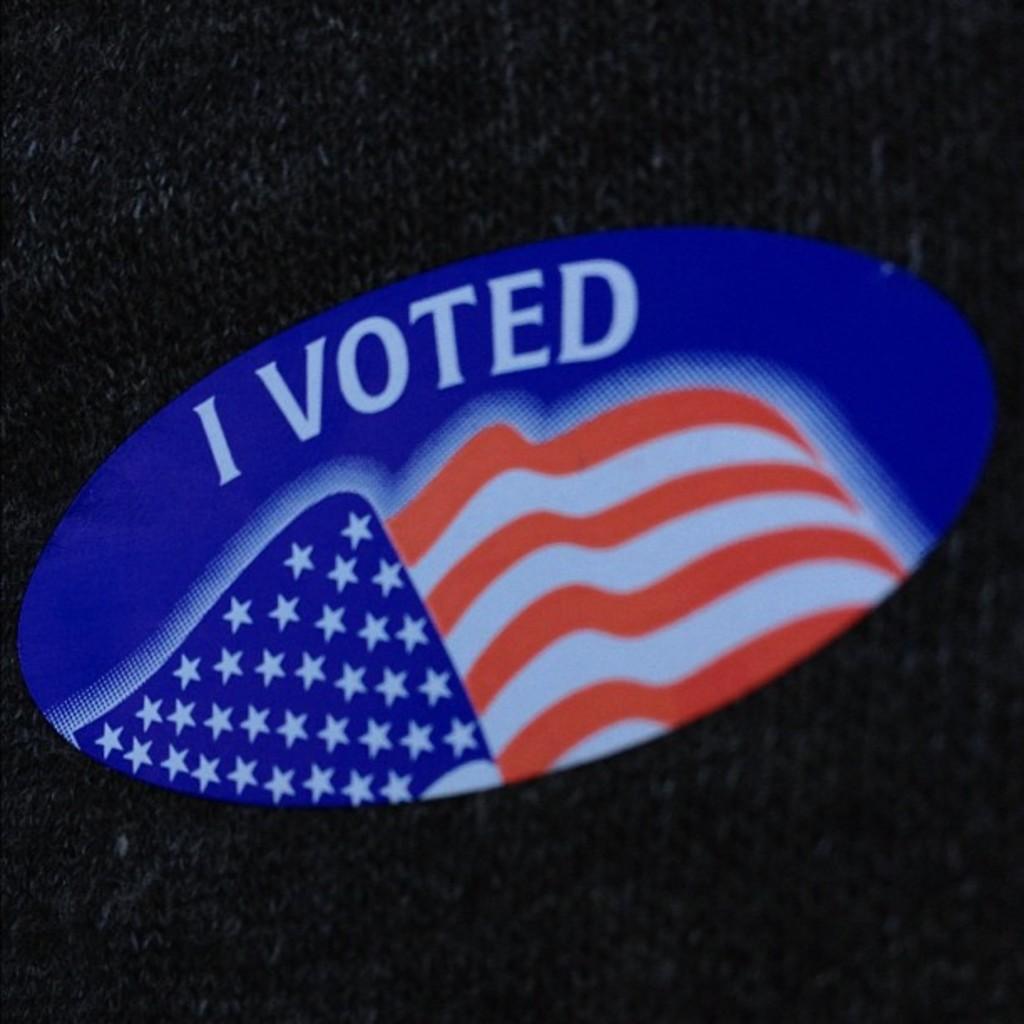How would you summarize this image in a sentence or two? In the center of the image we can see a lago, named as I voted. 